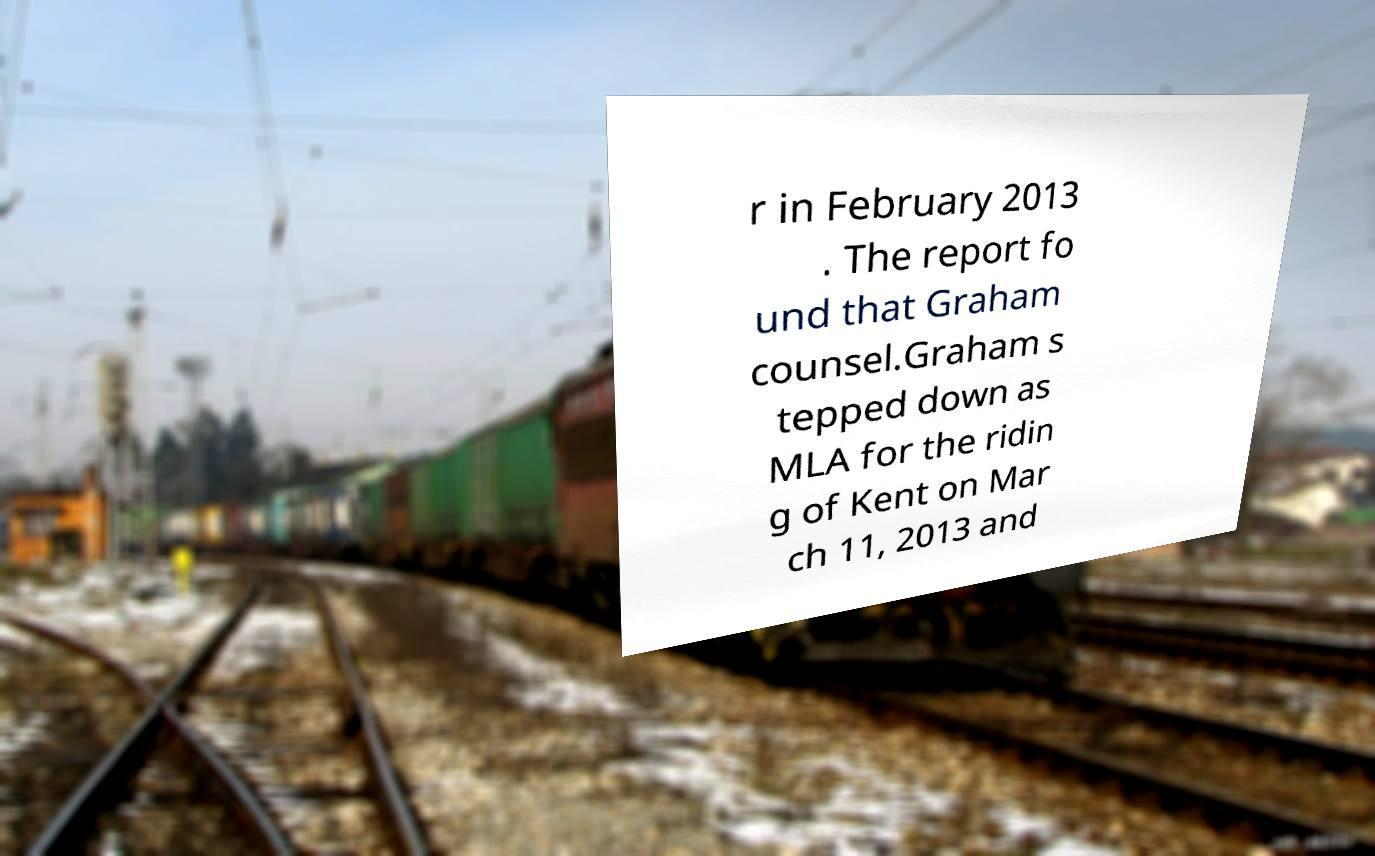For documentation purposes, I need the text within this image transcribed. Could you provide that? r in February 2013 . The report fo und that Graham counsel.Graham s tepped down as MLA for the ridin g of Kent on Mar ch 11, 2013 and 